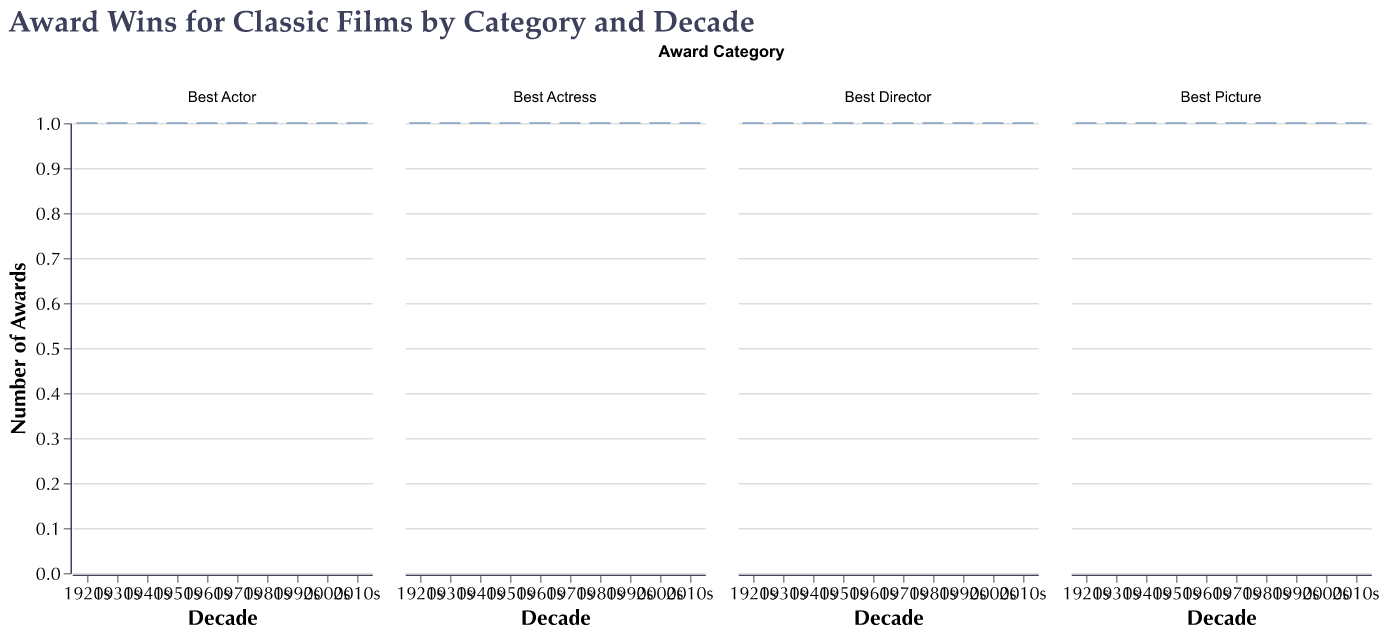What's the title of the figure? The title of the figure is displayed at the top and reads "Award Wins for Classic Films by Category and Decade".
Answer: Award Wins for Classic Films by Category and Decade What are the color of the median lines in the box plots? The median lines in the box plots are colored in red.
Answer: red How many different Award Categories are shown? The figure shows four different Award Categories divided into subplots: Best Picture, Best Director, Best Actor, and Best Actress.
Answer: 4 In which decade is there a box plot with an outlier? There are no outliers in any of the box plots because all values are 1.
Answer: none What is the range of the number of awards depicted in each category? Since every film listed in each category across all decades has a single award, the range of the number of awards in all categories is 1.
Answer: 1 Do any categories have a greater than 1 award for a single film? Observing all the box plots, each category shows an award count of exactly 1. There are no films with more than 1 award in any category.
Answer: no Compared to the other decades, how does the 1970s perform in the Best Actor Category? The 1970s in the Best Actor Category, represented by "Patton" with George C. Scott, also has just one award, similar to other decades.
Answer: the same Are there more films in the 'Best Actress' or 'Best Director' category? Both the 'Best Actress' and the 'Best Director' categories feature an equal number of films across the decades, each showing 10 awards.
Answer: equal Which category includes 'Gone with the Wind'? 'Gone with the Wind' is listed in the 'Best Picture' category for the 1930s.
Answer: Best Picture In what way is the data representation consistent across the subplots? Each subplot represents data with a box plot where every data point, represented by the films, has a value of 1 award. The subplots consistently depict the same statistical range and median, signifying uniformity.
Answer: consistent 